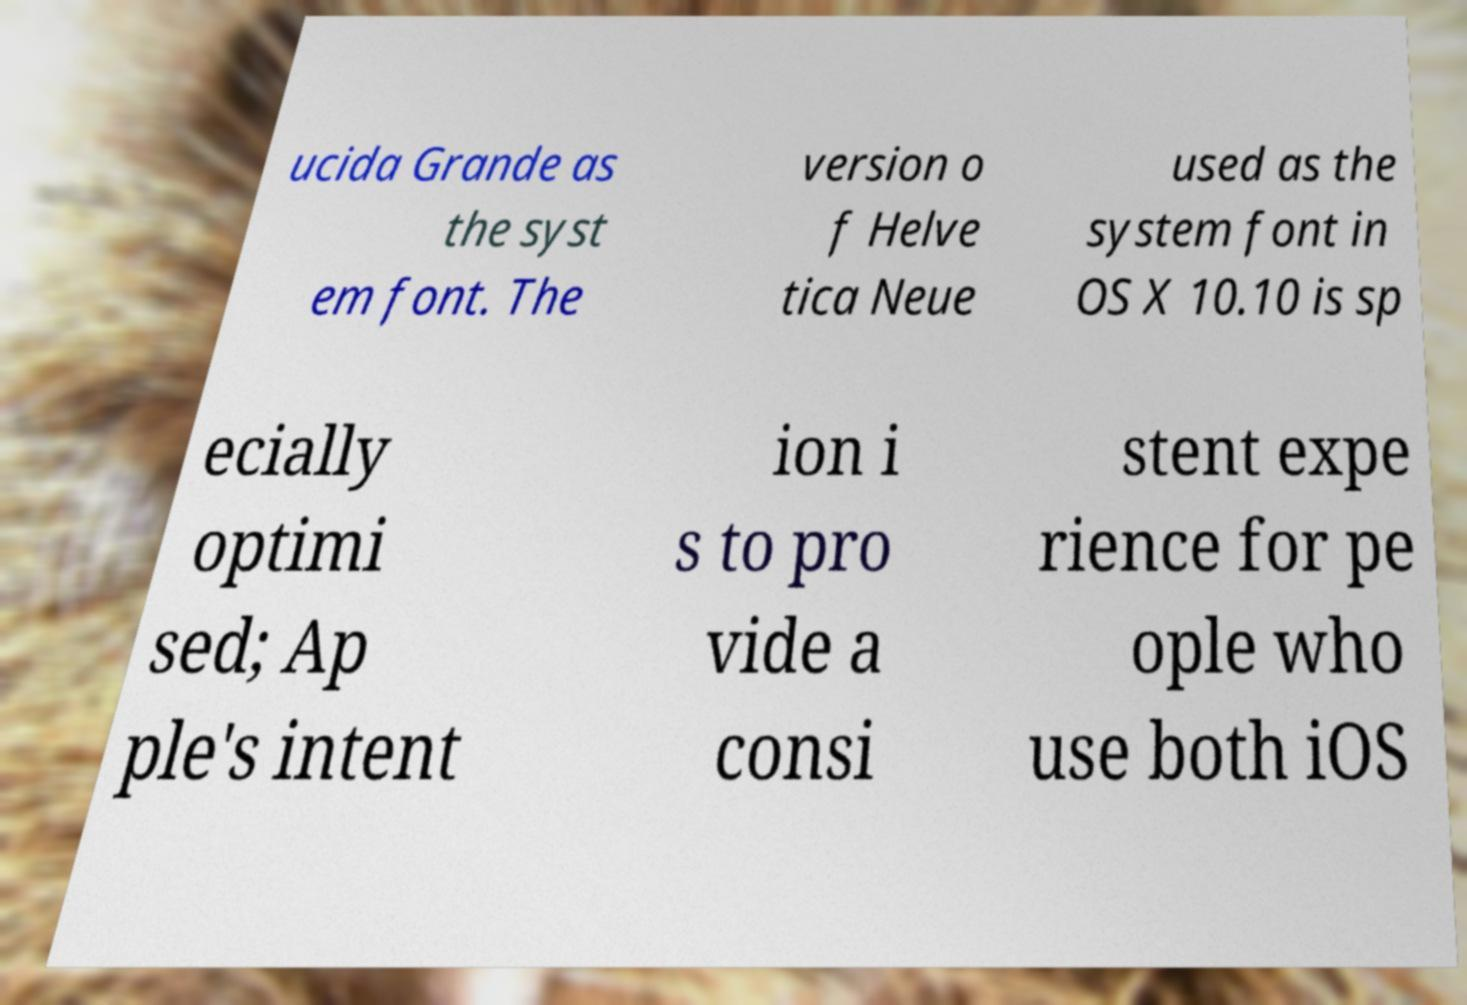Could you assist in decoding the text presented in this image and type it out clearly? ucida Grande as the syst em font. The version o f Helve tica Neue used as the system font in OS X 10.10 is sp ecially optimi sed; Ap ple's intent ion i s to pro vide a consi stent expe rience for pe ople who use both iOS 